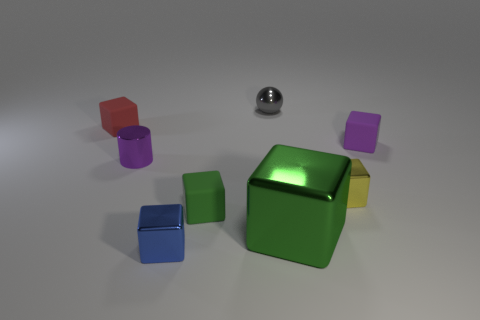If this image were part of a puzzle game, what might be the objective involving these objects? If this were a puzzle game, the objective might be to sort the cubes by color or stack them according to specific criteria, such as size or hue. Another potential game could involve using the reflective properties of the metallic sphere to direct a beam of light onto a target or through each of the colored cubes to achieve a certain effect or solve a riddle. 